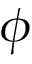Convert formula to latex. <formula><loc_0><loc_0><loc_500><loc_500>\phi</formula> 